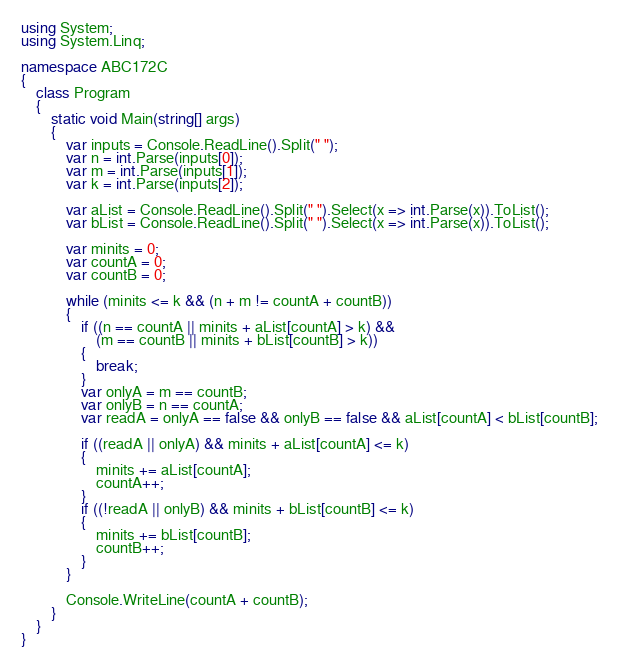Convert code to text. <code><loc_0><loc_0><loc_500><loc_500><_C#_>using System;
using System.Linq;

namespace ABC172C
{
    class Program
    {
        static void Main(string[] args)
        {
            var inputs = Console.ReadLine().Split(" ");
            var n = int.Parse(inputs[0]);
            var m = int.Parse(inputs[1]);
            var k = int.Parse(inputs[2]);

            var aList = Console.ReadLine().Split(" ").Select(x => int.Parse(x)).ToList();
            var bList = Console.ReadLine().Split(" ").Select(x => int.Parse(x)).ToList();

            var minits = 0;
            var countA = 0;
            var countB = 0;

            while (minits <= k && (n + m != countA + countB))
            {
                if ((n == countA || minits + aList[countA] > k) &&
                    (m == countB || minits + bList[countB] > k))
                {
                    break;
                }
                var onlyA = m == countB;
                var onlyB = n == countA;
                var readA = onlyA == false && onlyB == false && aList[countA] < bList[countB];

                if ((readA || onlyA) && minits + aList[countA] <= k)
                {
                    minits += aList[countA];
                    countA++;
                }
                if ((!readA || onlyB) && minits + bList[countB] <= k)
                {
                    minits += bList[countB];
                    countB++;
                }
            }

            Console.WriteLine(countA + countB);
        }
    }
}
</code> 